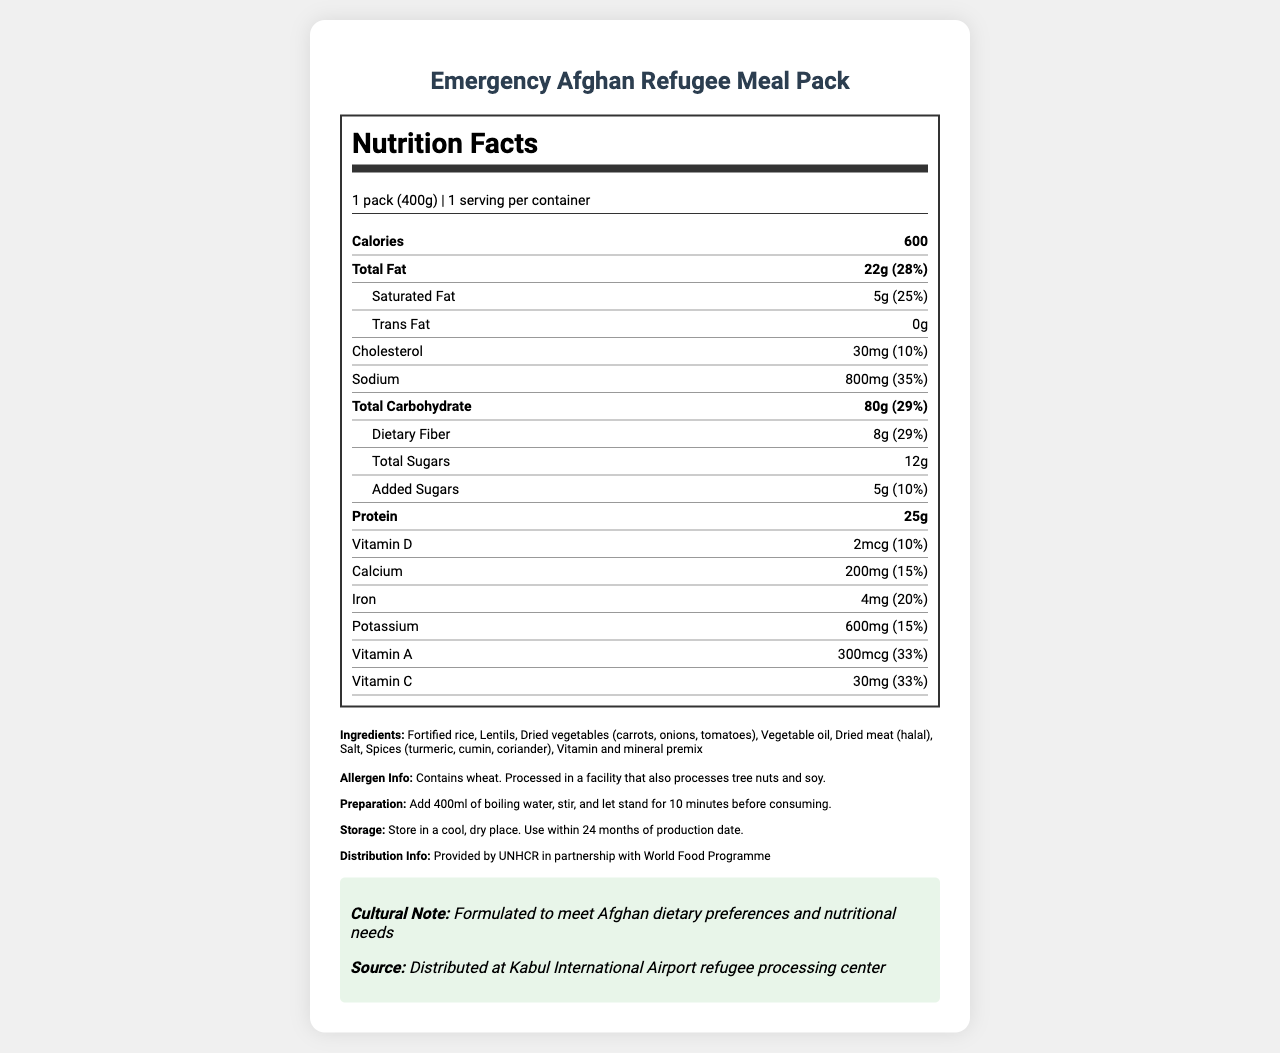what is the serving size for the Emergency Afghan Refugee Meal Pack? The serving size is mentioned at the beginning of the nutrition facts as "1 pack (400g)".
Answer: 1 pack (400g) How many calories are in one serving of this meal pack? The number of calories is listed near the top of the nutrition facts section as 600.
Answer: 600 What is the total fat content in one serving? The total fat content for one serving is stated as "22g (28%)".
Answer: 22g How much protein does one serving contain? The protein content for one serving is listed as 25g.
Answer: 25g What vitamins are listed on the nutrition label? The vitamins listed on the label are Vitamin D, Calcium, Iron, Potassium, Vitamin A, and Vitamin C.
Answer: Vitamin D, Calcium, Iron, Potassium, Vitamin A, Vitamin C How many mg of sodium does the meal pack contain? A. 600mg B. 800mg C. 1000mg The sodium content listed on the label is 800mg.
Answer: B. 800mg What is the daily value percentage for fiber in this meal pack? A. 20% B. 25% C. 29% D. 35% The daily value percentage for dietary fiber is shown as 29%.
Answer: C. 29% Does the meal pack contain any trans fats? The label indicates 0g of trans fat.
Answer: No Is it possible to find the expiry date for the meal pack on the label? The label specifies storage instructions and a recommended usage within 24 months of production but does not provide a specific expiry date.
Answer: Not enough information How is the Emergency Afghan Refugee Meal Pack prepared? The preparation instructions are clearly stated as adding 400ml of boiling water, stirring, and letting it stand for 10 minutes.
Answer: Add 400ml of boiling water, stir, and let stand for 10 minutes before consuming. Does the meal pack contain any allergens? The allergen information states that it contains wheat and is processed in a facility that also processes tree nuts and soy.
Answer: Yes Who provides and distributes the Emergency Afghan Refugee Meal Pack? The distribution information indicates that the meal pack is provided by UNHCR in partnership with the World Food Programme.
Answer: Provided by UNHCR in partnership with World Food Programme What is notable about the cultural aspect of this meal pack? The cultural note mentions that the meal pack is formulated to meet Afghan dietary preferences and nutritional needs.
Answer: Formulated to meet Afghan dietary preferences and nutritional needs Summarize the main idea of this nutrition facts label. This summary captures the key points detailed in the document regarding the nutritional content, preparation, and distribution of the meal pack along with its cultural relevance.
Answer: The Emergency Afghan Refugee Meal Pack is a nutritional product designed to meet the dietary needs and cultural preferences of Afghan refugees. It contains 600 calories per serving with a balanced mix of fats, carbohydrates, proteins, vitamins, and minerals. The product includes allergens like wheat and is easy to prepare. It is distributed by UNHCR and World Food Programme. 